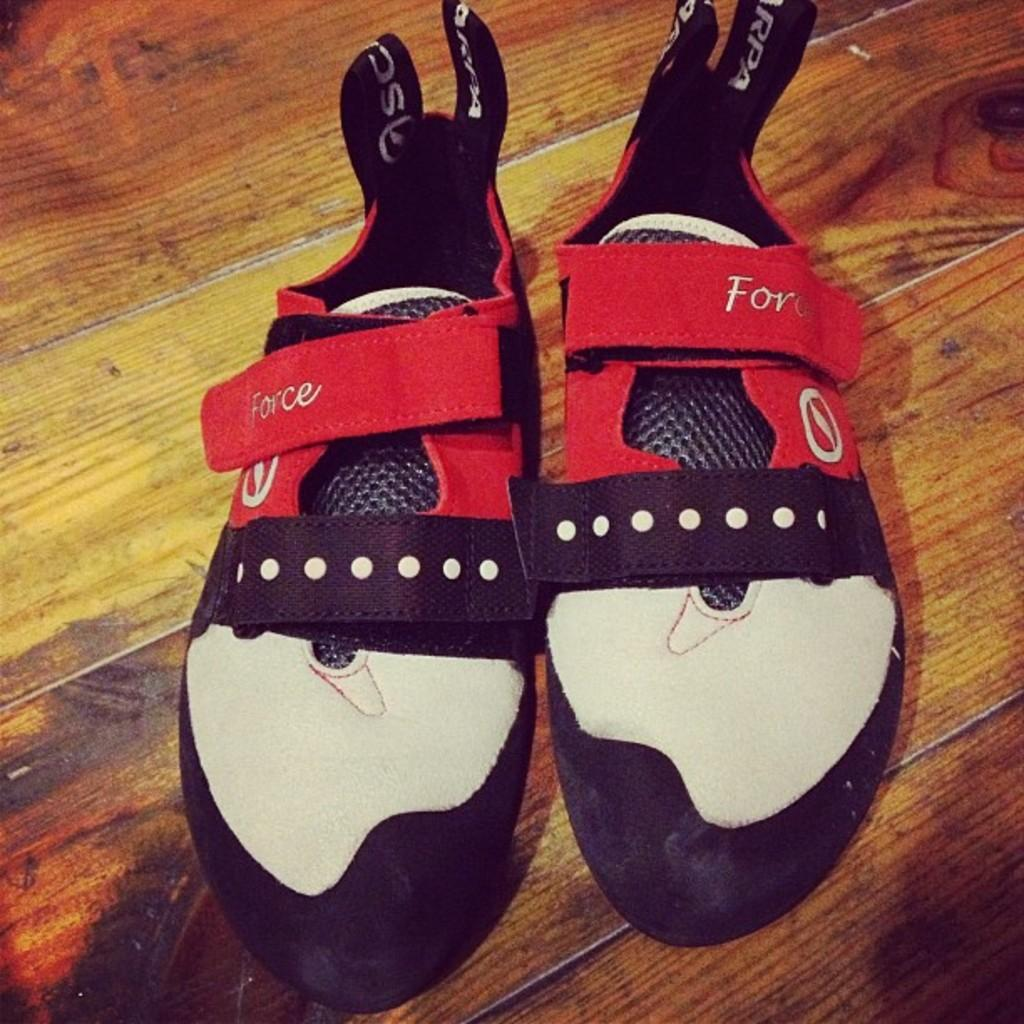What is placed on the floor in the image? There are shoes kept on the floor. Are the shoes accompanied by any other objects or figures? The image only shows shoes placed on the floor. How many tomatoes are placed inside the vase in the image? There is no vase or tomatoes present in the image; it only features shoes placed on the floor. 